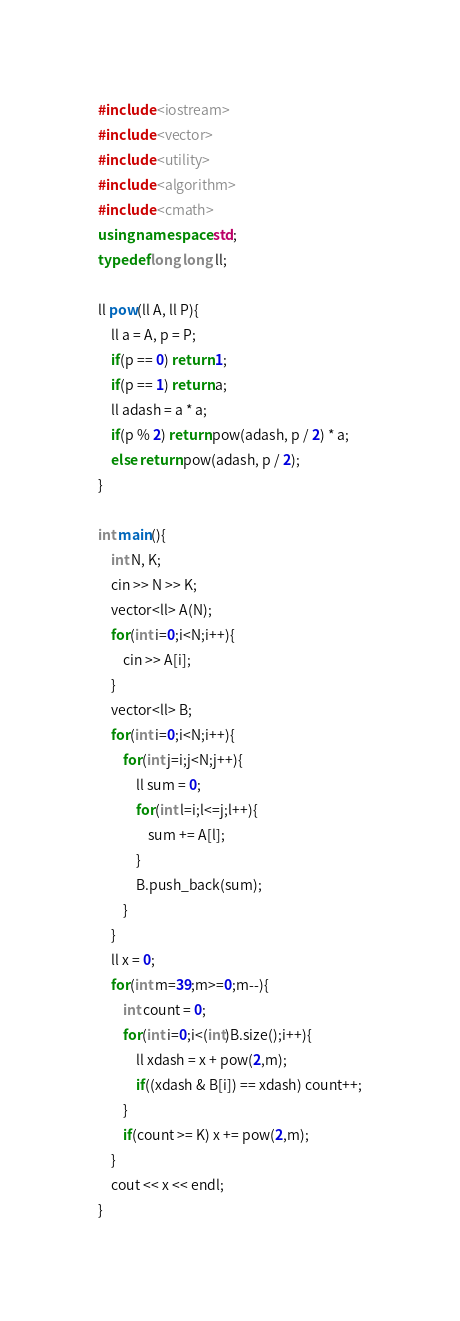<code> <loc_0><loc_0><loc_500><loc_500><_C++_>#include <iostream>
#include <vector>
#include <utility>
#include <algorithm>
#include <cmath>
using namespace std;
typedef long long ll;

ll pow(ll A, ll P){
	ll a = A, p = P;
	if(p == 0) return 1;
	if(p == 1) return a;
	ll adash = a * a;
	if(p % 2) return pow(adash, p / 2) * a;
	else return pow(adash, p / 2);
}

int main(){
	int N, K;
	cin >> N >> K;
	vector<ll> A(N);
	for(int i=0;i<N;i++){
		cin >> A[i];
	}
	vector<ll> B;
	for(int i=0;i<N;i++){
		for(int j=i;j<N;j++){
			ll sum = 0;
			for(int l=i;l<=j;l++){
				sum += A[l];
			}
			B.push_back(sum);
		}
	}
	ll x = 0;
	for(int m=39;m>=0;m--){
		int count = 0;
		for(int i=0;i<(int)B.size();i++){
			ll xdash = x + pow(2,m);
			if((xdash & B[i]) == xdash) count++;
		}
		if(count >= K) x += pow(2,m);
	}
	cout << x << endl;
}</code> 